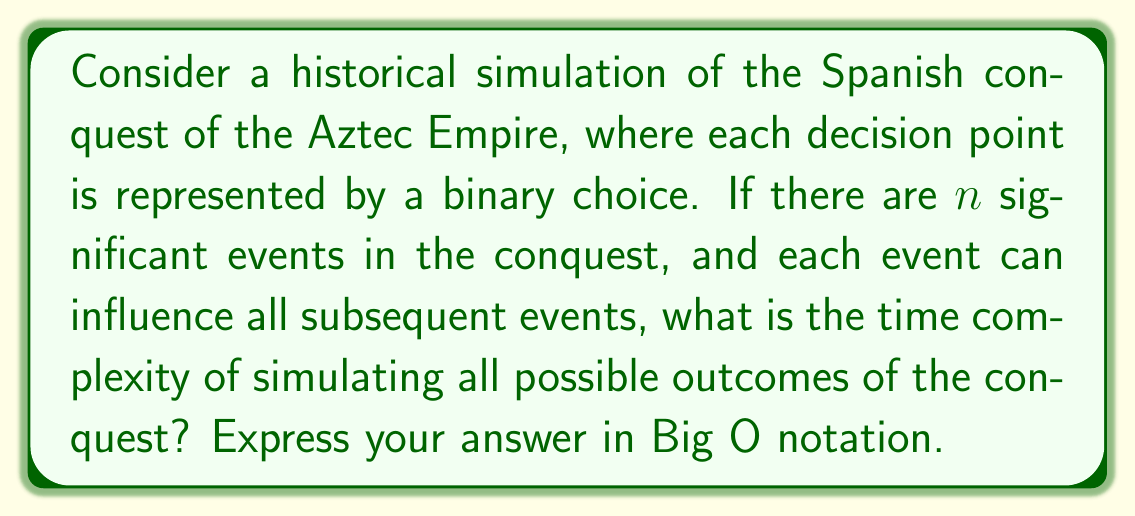What is the answer to this math problem? To analyze this problem, let's break it down step-by-step:

1) First, we need to understand what the input size is. In this case, it's $n$, the number of significant events in the conquest.

2) For each event, we have two possible choices. This creates a binary tree of possibilities.

3) The depth of this tree is $n$, as we have $n$ events in sequence.

4) In a binary tree of depth $n$, the number of leaf nodes (final outcomes) is $2^n$.

5) To simulate all possible outcomes, we need to traverse all paths from the root to each leaf. This means we'll be visiting every node in the tree.

6) In a binary tree, the total number of nodes is $2^{n+1} - 1$.

7) For each node, we assume a constant time operation (making a decision or recording an outcome).

8) Therefore, the total time to simulate all outcomes is proportional to the number of nodes in the tree.

9) In Big O notation, we typically drop constants and lower order terms. $2^{n+1} - 1$ simplifies to $O(2^n)$.

This exponential time complexity demonstrates why simulating all possible outcomes of complex historical scenarios quickly becomes computationally intractable as the number of events increases.
Answer: $O(2^n)$ 